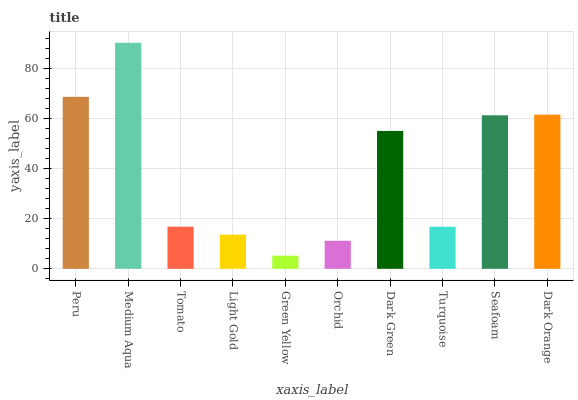Is Green Yellow the minimum?
Answer yes or no. Yes. Is Medium Aqua the maximum?
Answer yes or no. Yes. Is Tomato the minimum?
Answer yes or no. No. Is Tomato the maximum?
Answer yes or no. No. Is Medium Aqua greater than Tomato?
Answer yes or no. Yes. Is Tomato less than Medium Aqua?
Answer yes or no. Yes. Is Tomato greater than Medium Aqua?
Answer yes or no. No. Is Medium Aqua less than Tomato?
Answer yes or no. No. Is Dark Green the high median?
Answer yes or no. Yes. Is Tomato the low median?
Answer yes or no. Yes. Is Medium Aqua the high median?
Answer yes or no. No. Is Dark Orange the low median?
Answer yes or no. No. 